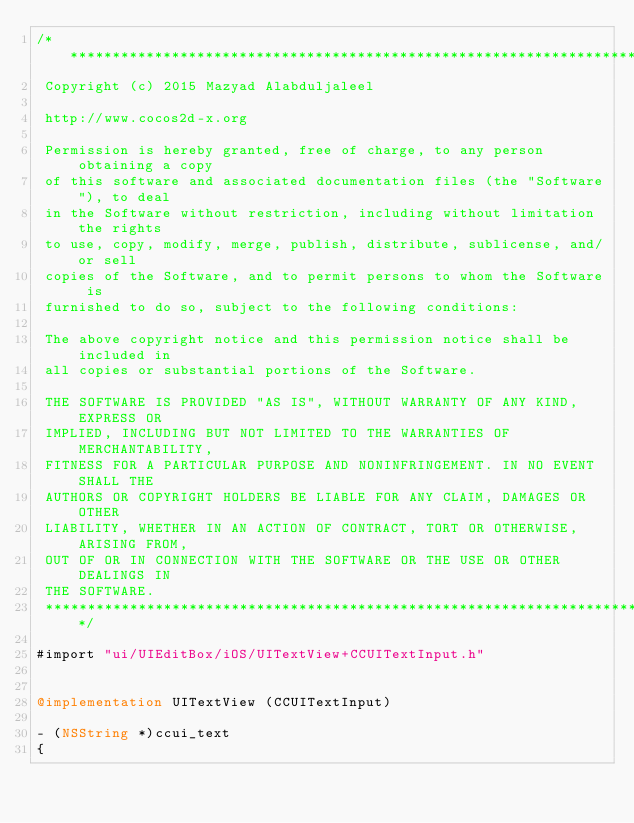Convert code to text. <code><loc_0><loc_0><loc_500><loc_500><_ObjectiveC_>/****************************************************************************
 Copyright (c) 2015 Mazyad Alabduljaleel
 
 http://www.cocos2d-x.org
 
 Permission is hereby granted, free of charge, to any person obtaining a copy
 of this software and associated documentation files (the "Software"), to deal
 in the Software without restriction, including without limitation the rights
 to use, copy, modify, merge, publish, distribute, sublicense, and/or sell
 copies of the Software, and to permit persons to whom the Software is
 furnished to do so, subject to the following conditions:
 
 The above copyright notice and this permission notice shall be included in
 all copies or substantial portions of the Software.
 
 THE SOFTWARE IS PROVIDED "AS IS", WITHOUT WARRANTY OF ANY KIND, EXPRESS OR
 IMPLIED, INCLUDING BUT NOT LIMITED TO THE WARRANTIES OF MERCHANTABILITY,
 FITNESS FOR A PARTICULAR PURPOSE AND NONINFRINGEMENT. IN NO EVENT SHALL THE
 AUTHORS OR COPYRIGHT HOLDERS BE LIABLE FOR ANY CLAIM, DAMAGES OR OTHER
 LIABILITY, WHETHER IN AN ACTION OF CONTRACT, TORT OR OTHERWISE, ARISING FROM,
 OUT OF OR IN CONNECTION WITH THE SOFTWARE OR THE USE OR OTHER DEALINGS IN
 THE SOFTWARE.
 ****************************************************************************/

#import "ui/UIEditBox/iOS/UITextView+CCUITextInput.h"


@implementation UITextView (CCUITextInput)

- (NSString *)ccui_text
{</code> 